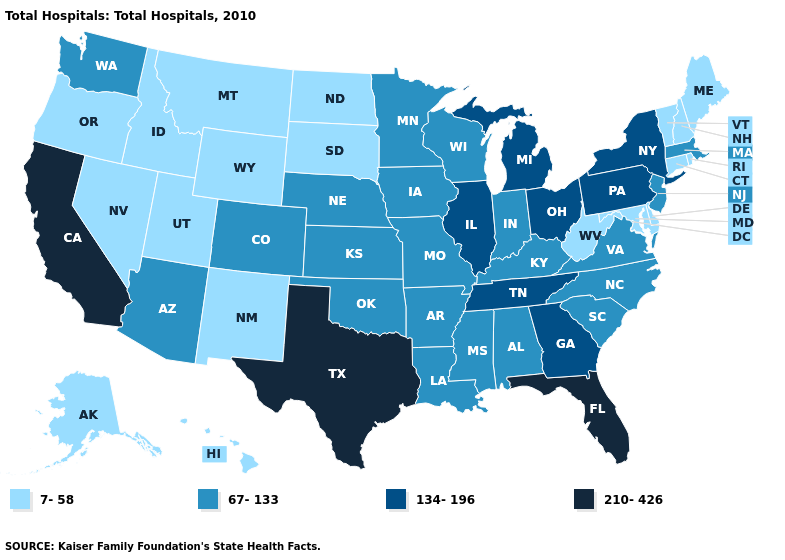Name the states that have a value in the range 210-426?
Quick response, please. California, Florida, Texas. Name the states that have a value in the range 7-58?
Concise answer only. Alaska, Connecticut, Delaware, Hawaii, Idaho, Maine, Maryland, Montana, Nevada, New Hampshire, New Mexico, North Dakota, Oregon, Rhode Island, South Dakota, Utah, Vermont, West Virginia, Wyoming. Does Ohio have the highest value in the MidWest?
Concise answer only. Yes. Which states have the highest value in the USA?
Give a very brief answer. California, Florida, Texas. Among the states that border Minnesota , which have the highest value?
Answer briefly. Iowa, Wisconsin. What is the highest value in states that border Maine?
Keep it brief. 7-58. What is the highest value in states that border Wisconsin?
Keep it brief. 134-196. What is the value of Missouri?
Short answer required. 67-133. What is the lowest value in the Northeast?
Give a very brief answer. 7-58. What is the highest value in states that border Massachusetts?
Be succinct. 134-196. Does Minnesota have the highest value in the MidWest?
Be succinct. No. What is the highest value in the West ?
Be succinct. 210-426. What is the lowest value in the Northeast?
Write a very short answer. 7-58. Among the states that border Indiana , does Michigan have the highest value?
Answer briefly. Yes. 